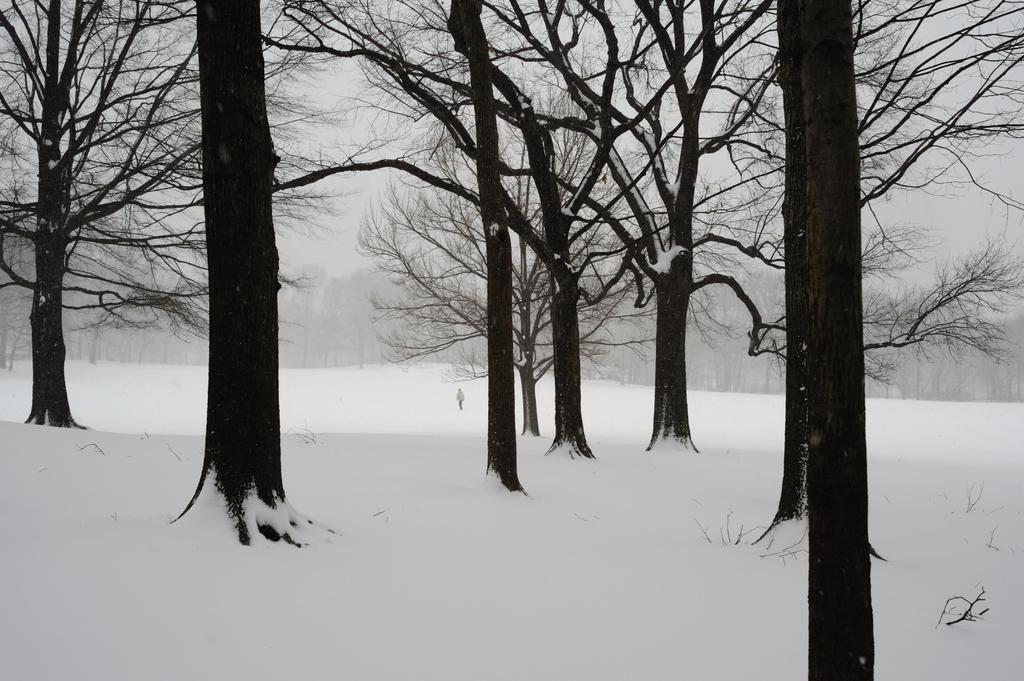In one or two sentences, can you explain what this image depicts? In the center of the image there is a person on the snow. In the background there is a snow, trees and sky. 